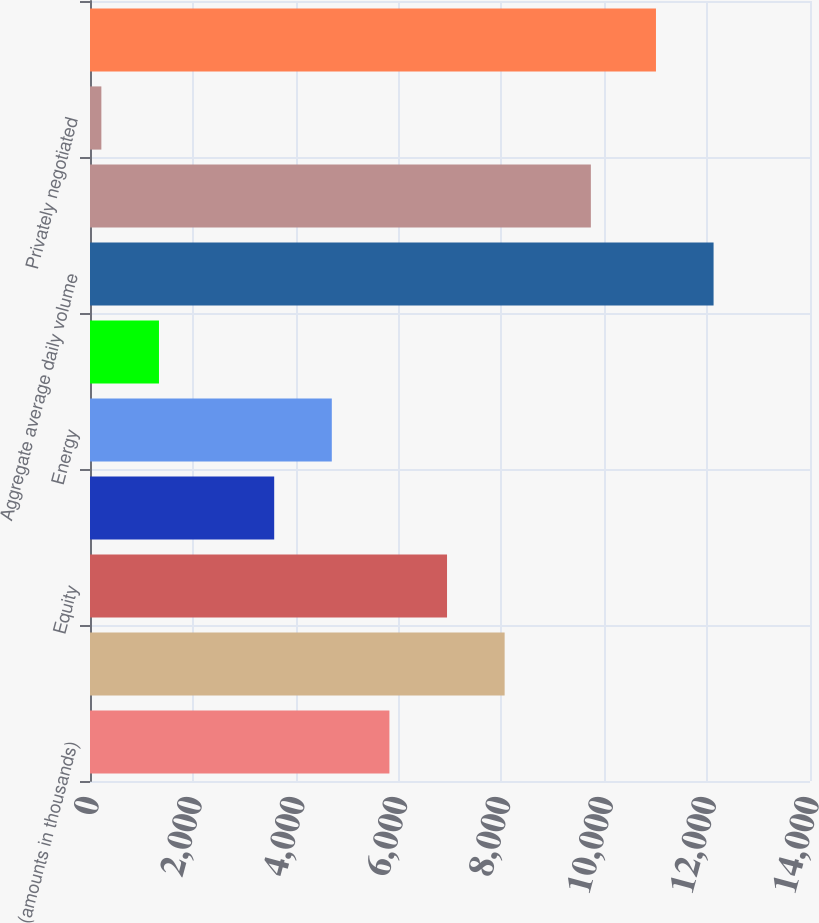Convert chart to OTSL. <chart><loc_0><loc_0><loc_500><loc_500><bar_chart><fcel>(amounts in thousands)<fcel>Interest rate<fcel>Equity<fcel>Agricultural commodity (1)<fcel>Energy<fcel>Metal<fcel>Aggregate average daily volume<fcel>Electronic<fcel>Privately negotiated<fcel>Total exchange-traded volume<nl><fcel>5822<fcel>8062.4<fcel>6942.2<fcel>3581.6<fcel>4701.8<fcel>1341.2<fcel>12125.2<fcel>9739<fcel>221<fcel>11005<nl></chart> 